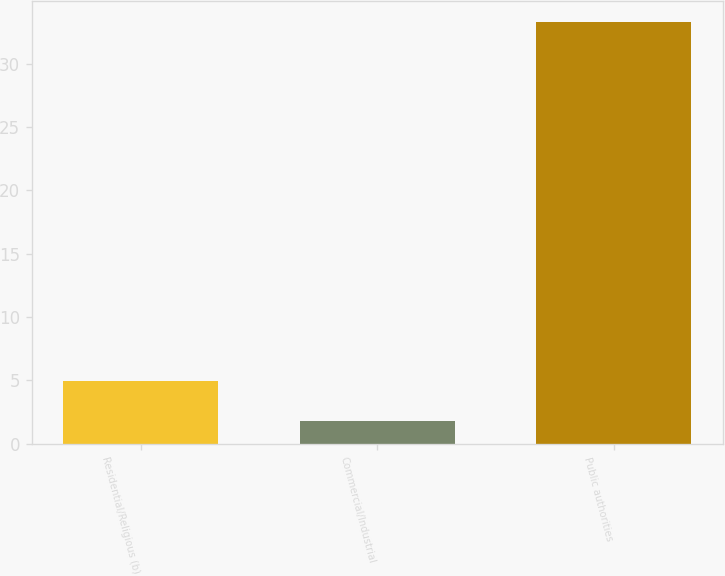<chart> <loc_0><loc_0><loc_500><loc_500><bar_chart><fcel>Residential/Religious (b)<fcel>Commercial/Industrial<fcel>Public authorities<nl><fcel>4.95<fcel>1.8<fcel>33.3<nl></chart> 